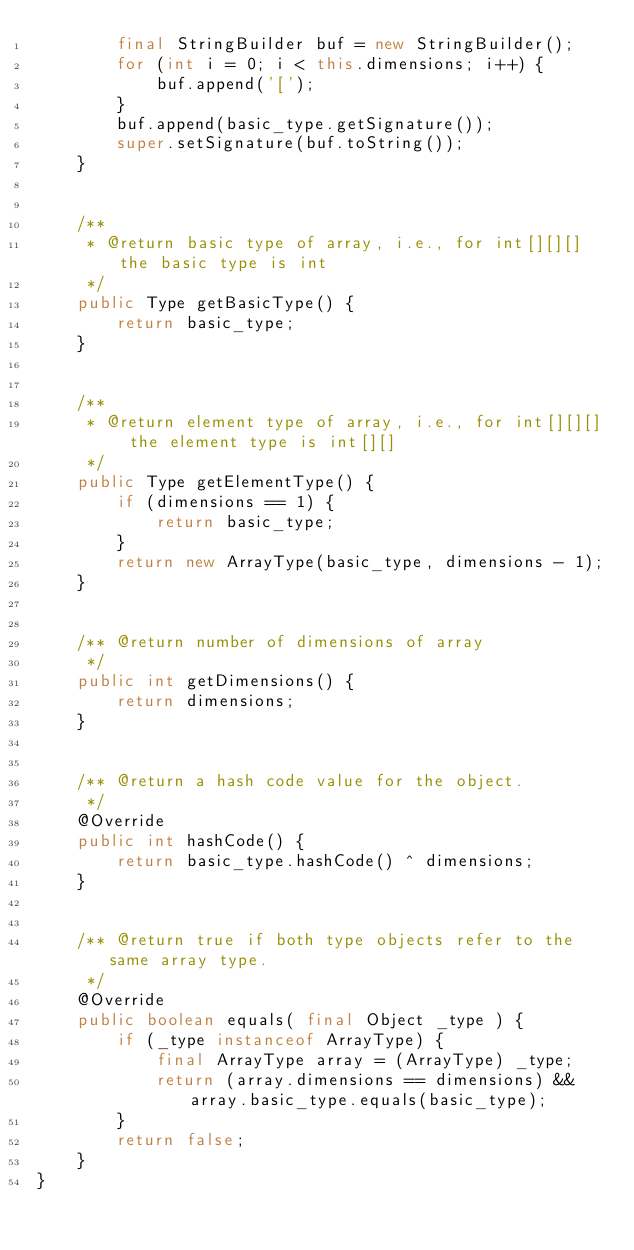Convert code to text. <code><loc_0><loc_0><loc_500><loc_500><_Java_>        final StringBuilder buf = new StringBuilder();
        for (int i = 0; i < this.dimensions; i++) {
            buf.append('[');
        }
        buf.append(basic_type.getSignature());
        super.setSignature(buf.toString());
    }


    /**
     * @return basic type of array, i.e., for int[][][] the basic type is int
     */
    public Type getBasicType() {
        return basic_type;
    }


    /**
     * @return element type of array, i.e., for int[][][] the element type is int[][]
     */
    public Type getElementType() {
        if (dimensions == 1) {
            return basic_type;
        }
        return new ArrayType(basic_type, dimensions - 1);
    }


    /** @return number of dimensions of array
     */
    public int getDimensions() {
        return dimensions;
    }


    /** @return a hash code value for the object.
     */
    @Override
    public int hashCode() {
        return basic_type.hashCode() ^ dimensions;
    }


    /** @return true if both type objects refer to the same array type.
     */
    @Override
    public boolean equals( final Object _type ) {
        if (_type instanceof ArrayType) {
            final ArrayType array = (ArrayType) _type;
            return (array.dimensions == dimensions) && array.basic_type.equals(basic_type);
        }
        return false;
    }
}
</code> 